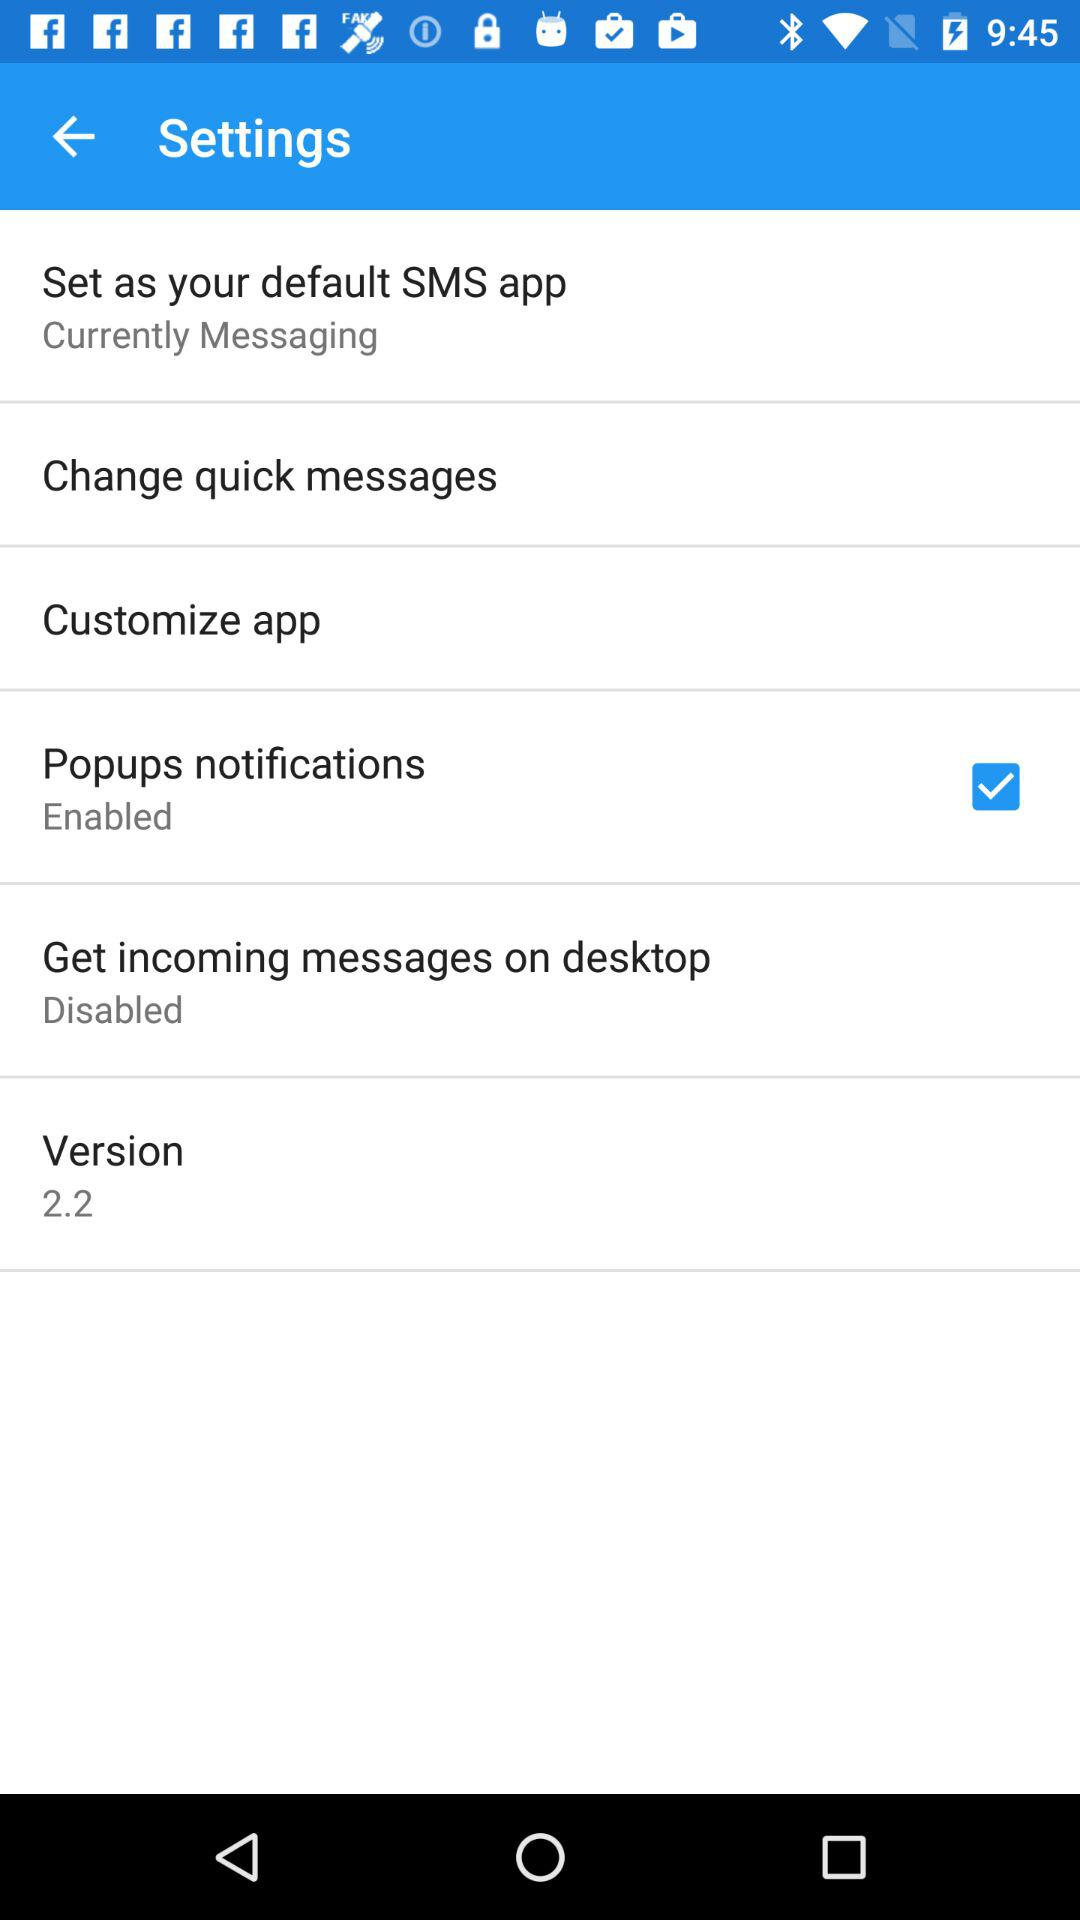What is the status of "Get incoming messages on desktop"? The status of "Get incoming messages on desktop" is "Disabled". 